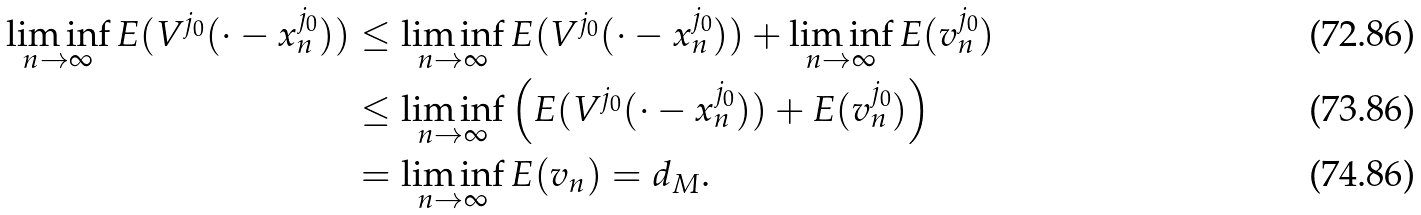<formula> <loc_0><loc_0><loc_500><loc_500>\liminf _ { n \rightarrow \infty } E ( V ^ { j _ { 0 } } ( \cdot - x ^ { j _ { 0 } } _ { n } ) ) & \leq \liminf _ { n \rightarrow \infty } E ( V ^ { j _ { 0 } } ( \cdot - x ^ { j _ { 0 } } _ { n } ) ) + \liminf _ { n \rightarrow \infty } E ( v ^ { j _ { 0 } } _ { n } ) \\ & \leq \liminf _ { n \rightarrow \infty } \left ( E ( V ^ { j _ { 0 } } ( \cdot - x ^ { j _ { 0 } } _ { n } ) ) + E ( v ^ { j _ { 0 } } _ { n } ) \right ) \\ & = \liminf _ { n \rightarrow \infty } E ( v _ { n } ) = d _ { M } .</formula> 